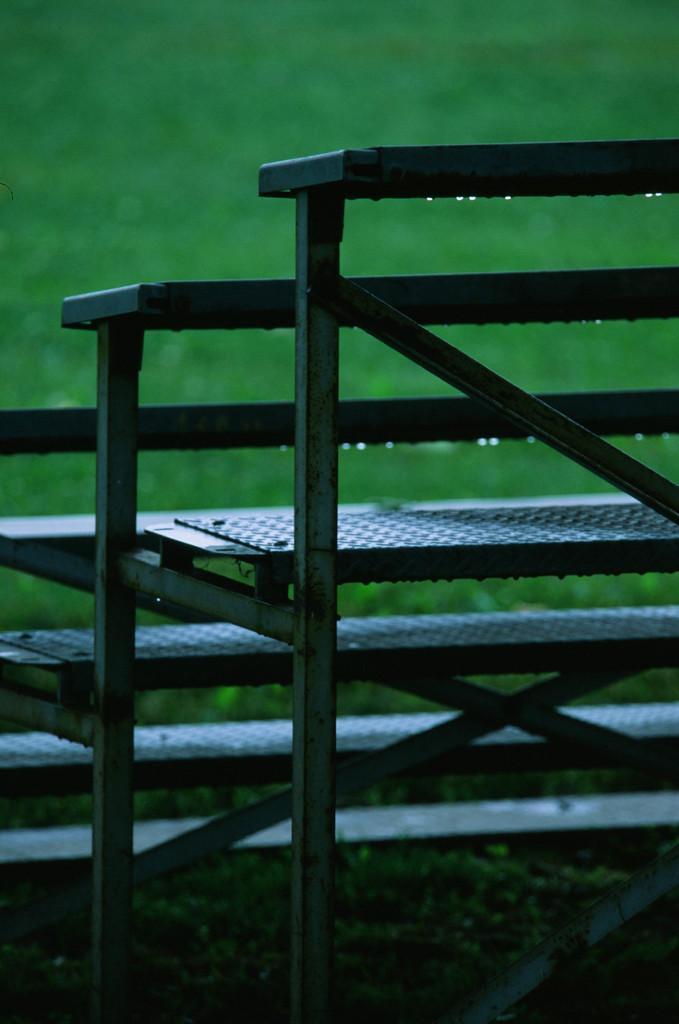Can you describe this image briefly? In this picture we can see steps and this is grass. 